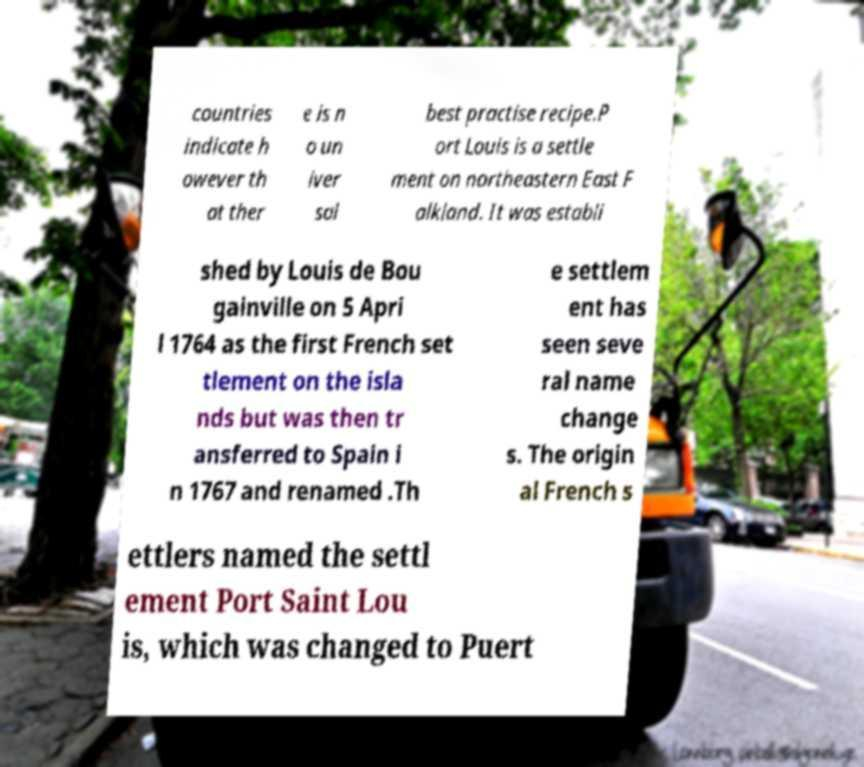Please read and relay the text visible in this image. What does it say? countries indicate h owever th at ther e is n o un iver sal best practise recipe.P ort Louis is a settle ment on northeastern East F alkland. It was establi shed by Louis de Bou gainville on 5 Apri l 1764 as the first French set tlement on the isla nds but was then tr ansferred to Spain i n 1767 and renamed .Th e settlem ent has seen seve ral name change s. The origin al French s ettlers named the settl ement Port Saint Lou is, which was changed to Puert 